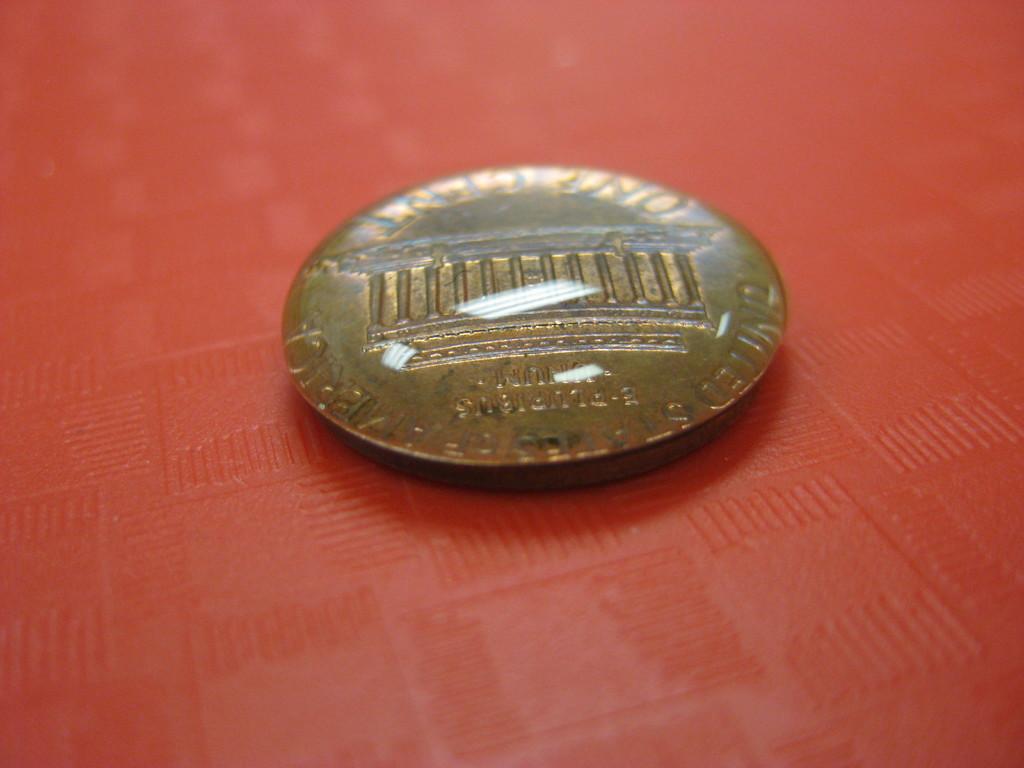What is the value of the coin?
Offer a very short reply. One cent. Which country does it originate from?
Provide a short and direct response. United states. 